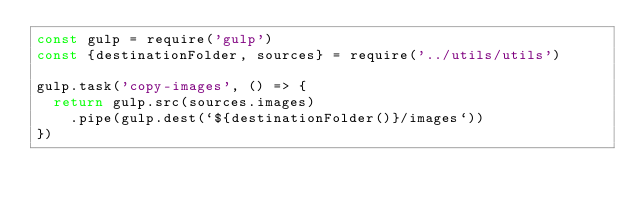Convert code to text. <code><loc_0><loc_0><loc_500><loc_500><_JavaScript_>const gulp = require('gulp')
const {destinationFolder, sources} = require('../utils/utils')

gulp.task('copy-images', () => {
  return gulp.src(sources.images)
    .pipe(gulp.dest(`${destinationFolder()}/images`))
})
</code> 